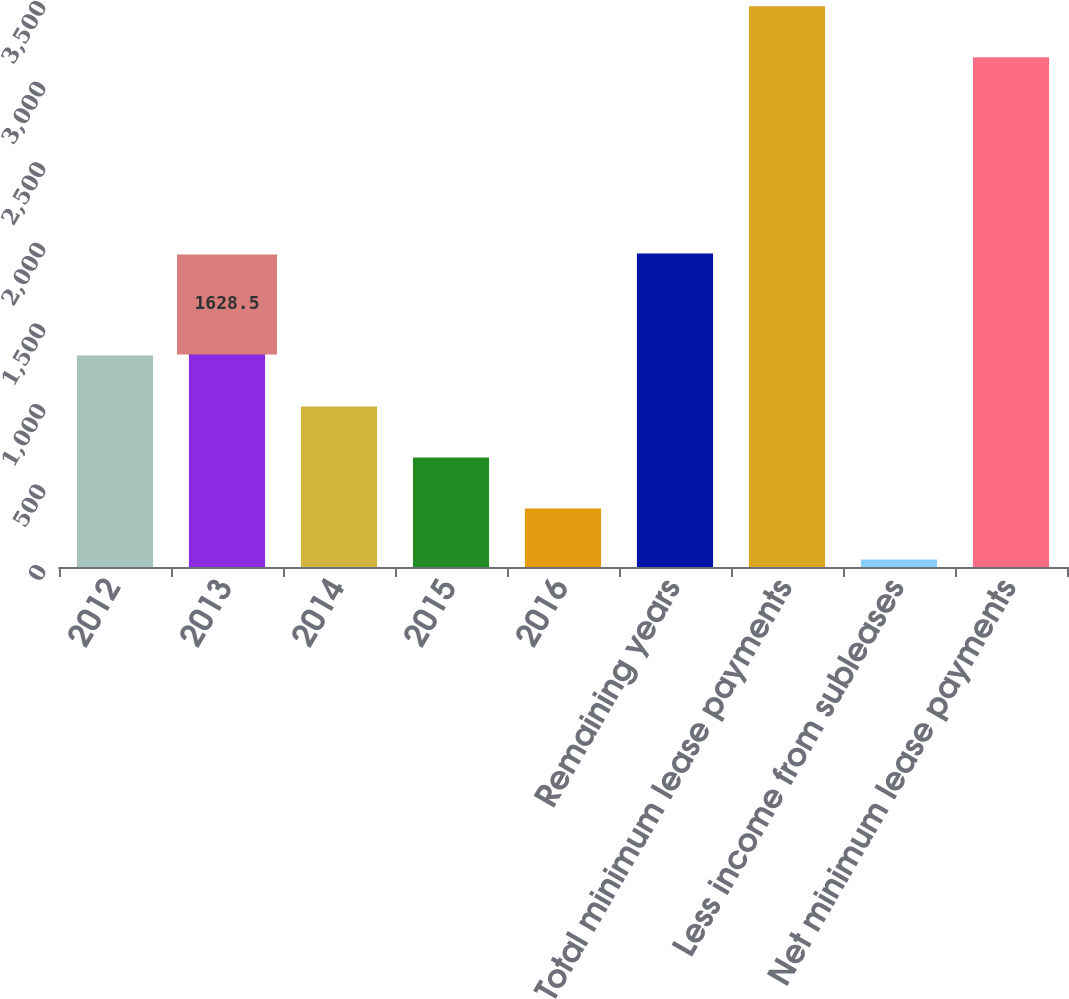<chart> <loc_0><loc_0><loc_500><loc_500><bar_chart><fcel>2012<fcel>2013<fcel>2014<fcel>2015<fcel>2016<fcel>Remaining years<fcel>Total minimum lease payments<fcel>Less income from subleases<fcel>Net minimum lease payments<nl><fcel>1312.2<fcel>1628.5<fcel>995.9<fcel>679.6<fcel>363.3<fcel>1944.8<fcel>3479.3<fcel>47<fcel>3163<nl></chart> 